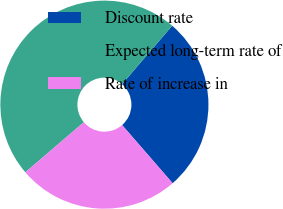<chart> <loc_0><loc_0><loc_500><loc_500><pie_chart><fcel>Discount rate<fcel>Expected long-term rate of<fcel>Rate of increase in<nl><fcel>27.33%<fcel>47.56%<fcel>25.12%<nl></chart> 